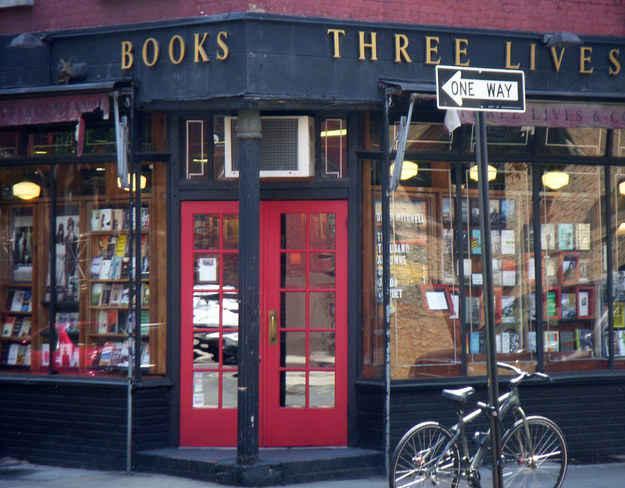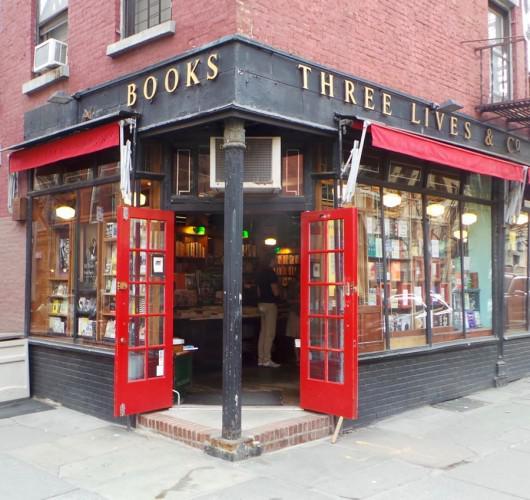The first image is the image on the left, the second image is the image on the right. Considering the images on both sides, is "A single two-wheeled vehicle is parked in front of a shop with red double doors." valid? Answer yes or no. Yes. The first image is the image on the left, the second image is the image on the right. Evaluate the accuracy of this statement regarding the images: "The building on the right image has a closed red door while the building on the other side does not.". Is it true? Answer yes or no. No. 